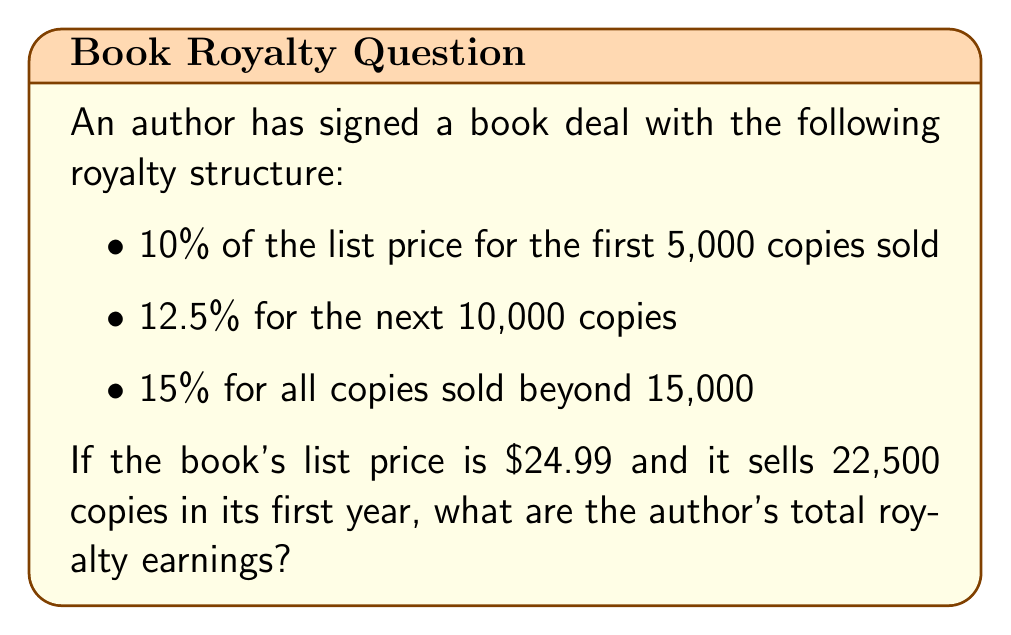Could you help me with this problem? Let's break this down step-by-step:

1. First 5,000 copies:
   Royalty rate: 10%
   Earnings: $5,000 \times (0.10 \times \$24.99) = \$1,249.50$

2. Next 10,000 copies:
   Royalty rate: 12.5%
   Earnings: $10,000 \times (0.125 \times \$24.99) = \$3,123.75$

3. Remaining 7,500 copies (22,500 - 15,000):
   Royalty rate: 15%
   Earnings: $7,500 \times (0.15 \times \$24.99) = \$2,811.38$

4. Total earnings:
   $$\text{Total} = \$1,249.50 + \$3,123.75 + \$2,811.38 = \$7,184.63$$

Therefore, the author's total royalty earnings for the first year are $7,184.63.
Answer: $7,184.63 